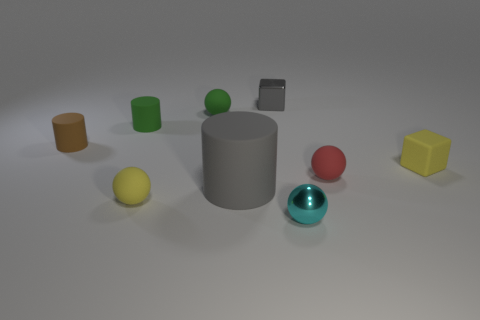Subtract all yellow matte balls. How many balls are left? 3 Add 1 big cyan rubber balls. How many objects exist? 10 Subtract all gray cylinders. How many cylinders are left? 2 Subtract all cylinders. How many objects are left? 6 Subtract 2 cylinders. How many cylinders are left? 1 Subtract all green blocks. How many green cylinders are left? 1 Subtract all red matte things. Subtract all cylinders. How many objects are left? 5 Add 1 big gray matte things. How many big gray matte things are left? 2 Add 1 gray metal balls. How many gray metal balls exist? 1 Subtract 0 brown balls. How many objects are left? 9 